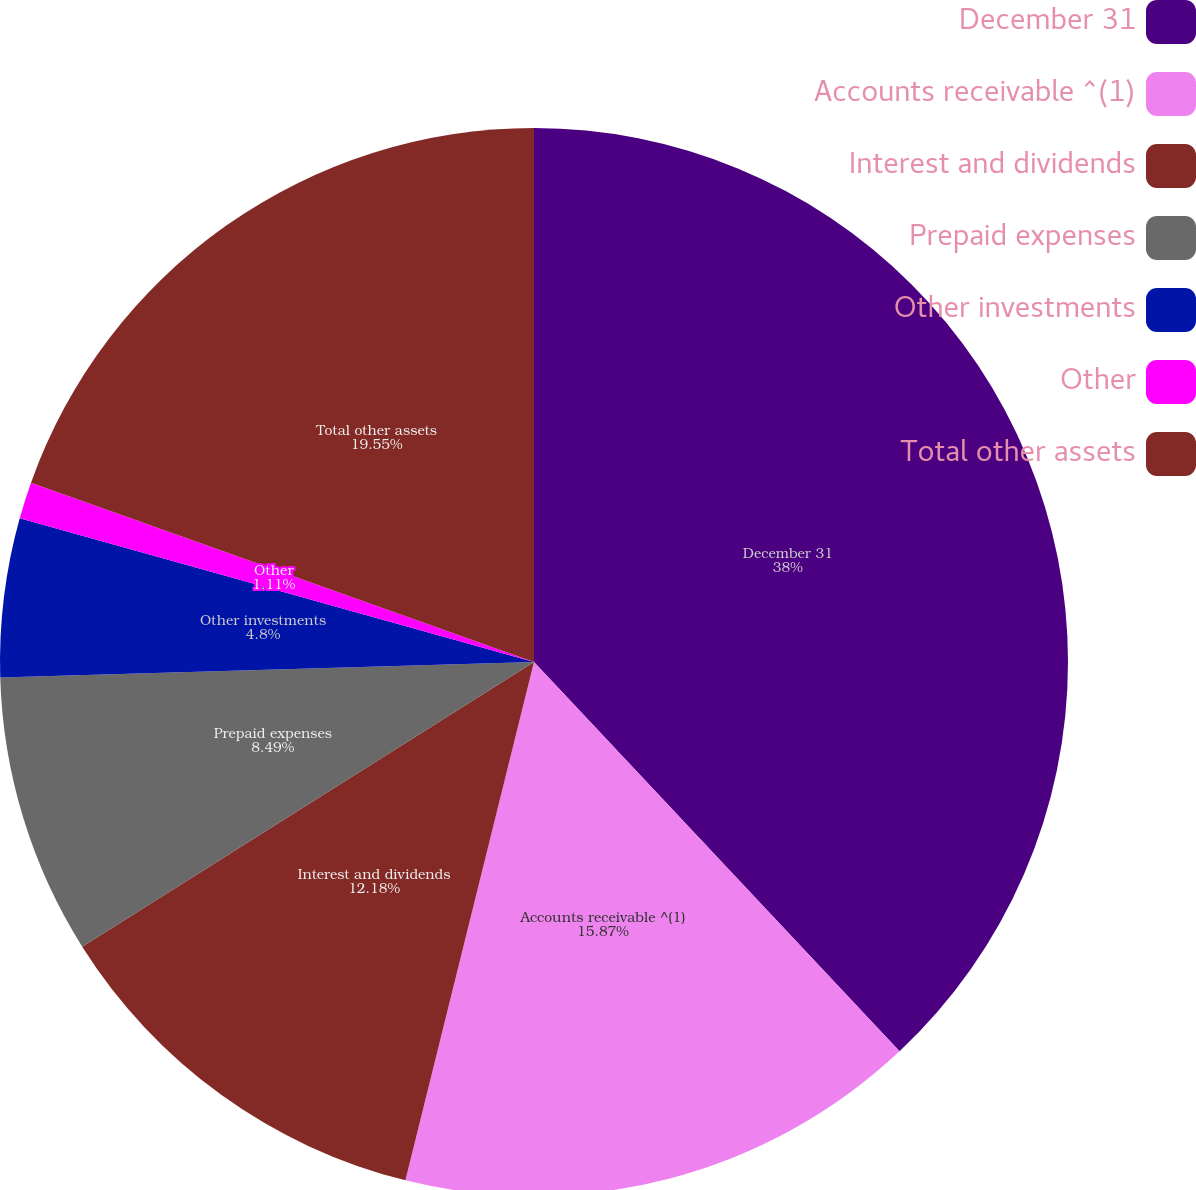Convert chart. <chart><loc_0><loc_0><loc_500><loc_500><pie_chart><fcel>December 31<fcel>Accounts receivable ^(1)<fcel>Interest and dividends<fcel>Prepaid expenses<fcel>Other investments<fcel>Other<fcel>Total other assets<nl><fcel>38.0%<fcel>15.87%<fcel>12.18%<fcel>8.49%<fcel>4.8%<fcel>1.11%<fcel>19.55%<nl></chart> 